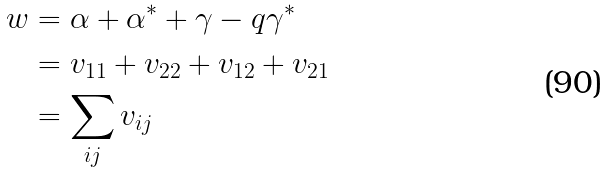<formula> <loc_0><loc_0><loc_500><loc_500>w & = \alpha + \alpha ^ { * } + \gamma - q \gamma ^ { * } \\ & = v _ { 1 1 } + v _ { 2 2 } + v _ { 1 2 } + v _ { 2 1 } \\ & = \sum _ { i j } v _ { i j }</formula> 